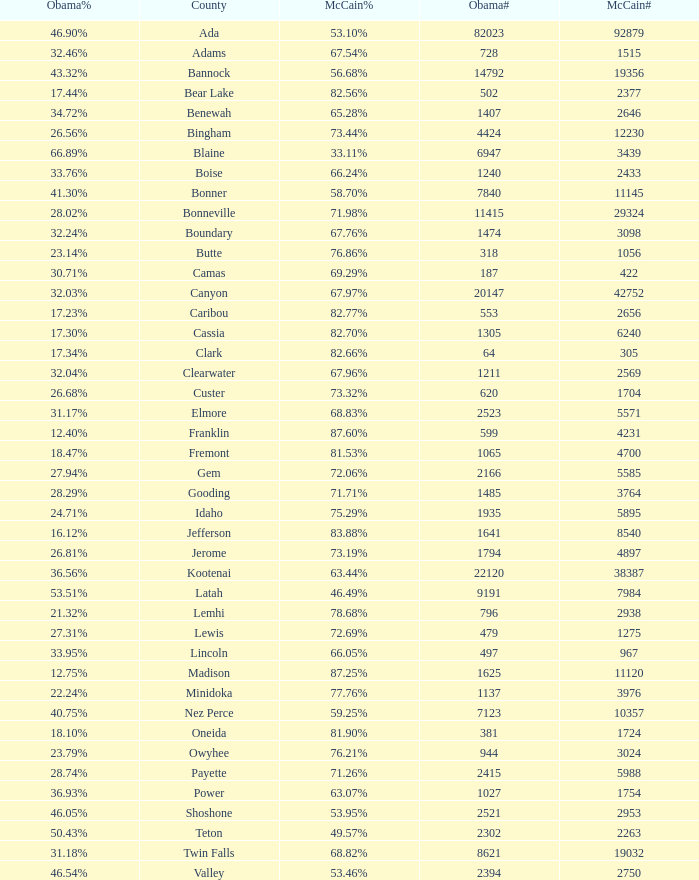For Gem County, what was the Obama vote percentage? 27.94%. 